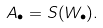<formula> <loc_0><loc_0><loc_500><loc_500>A _ { \bullet } = S ( W _ { \bullet } ) .</formula> 